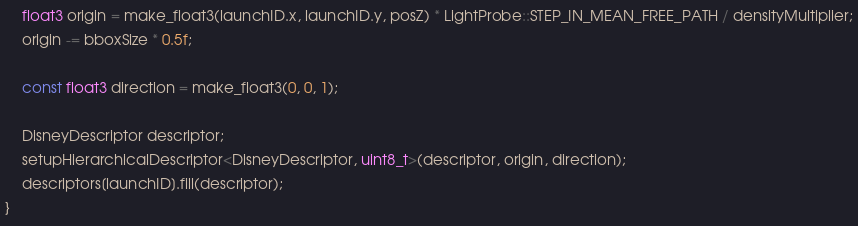<code> <loc_0><loc_0><loc_500><loc_500><_Cuda_>    float3 origin = make_float3(launchID.x, launchID.y, posZ) * LightProbe::STEP_IN_MEAN_FREE_PATH / densityMultiplier;
    origin -= bboxSize * 0.5f;

    const float3 direction = make_float3(0, 0, 1);

    DisneyDescriptor descriptor;
    setupHierarchicalDescriptor<DisneyDescriptor, uint8_t>(descriptor, origin, direction);
    descriptors[launchID].fill(descriptor);
}</code> 